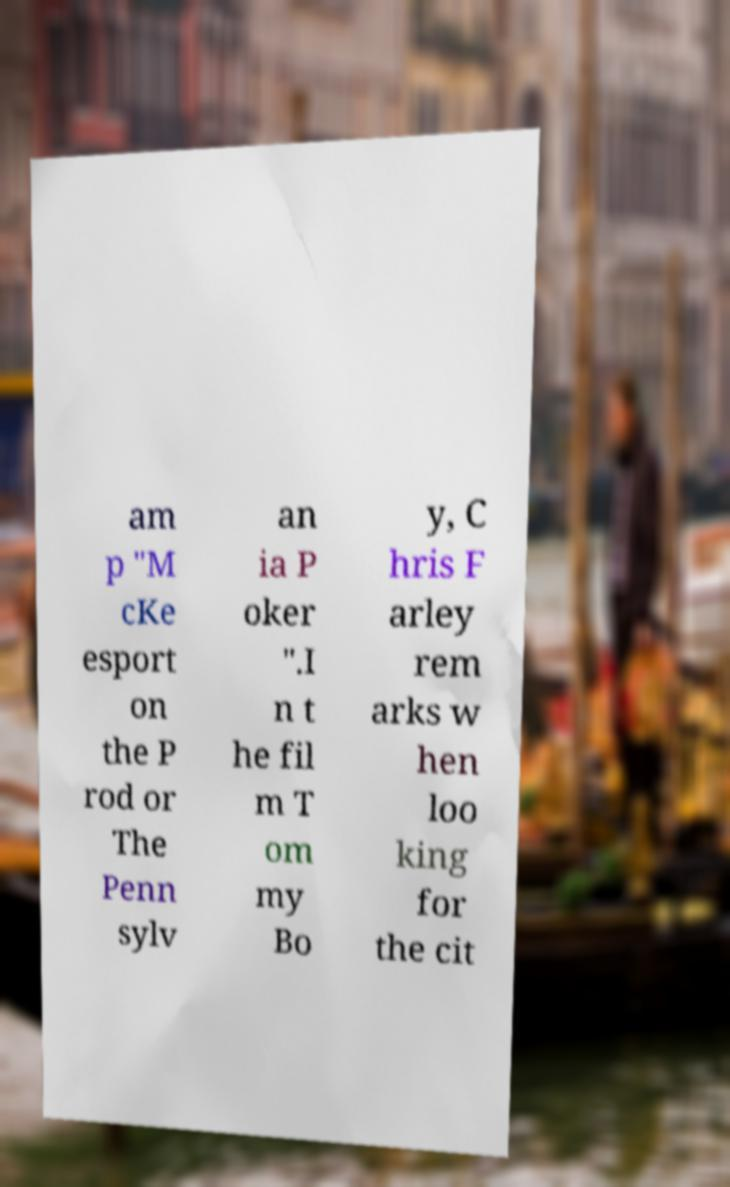Could you extract and type out the text from this image? am p "M cKe esport on the P rod or The Penn sylv an ia P oker ".I n t he fil m T om my Bo y, C hris F arley rem arks w hen loo king for the cit 